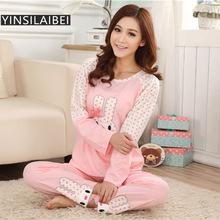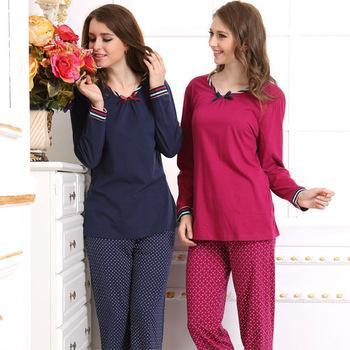The first image is the image on the left, the second image is the image on the right. Evaluate the accuracy of this statement regarding the images: "All of the girls are wearing pajamas with cartoon characters on them.". Is it true? Answer yes or no. No. 